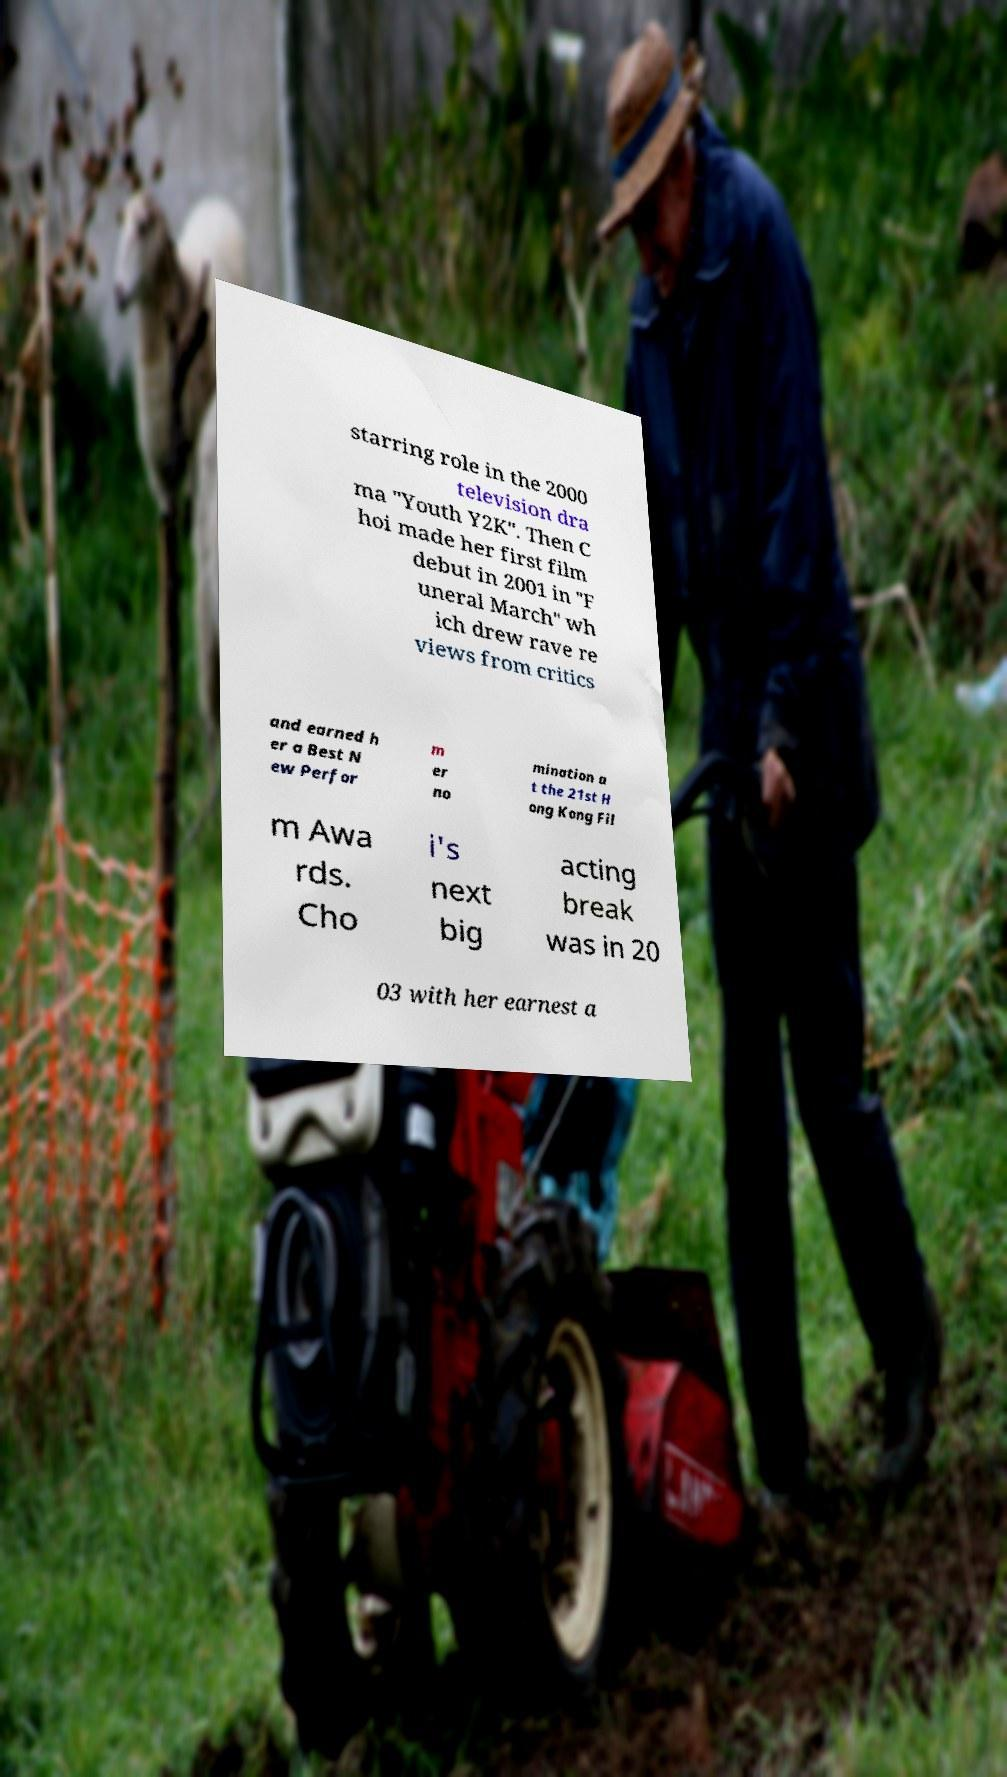Can you read and provide the text displayed in the image?This photo seems to have some interesting text. Can you extract and type it out for me? starring role in the 2000 television dra ma "Youth Y2K". Then C hoi made her first film debut in 2001 in "F uneral March" wh ich drew rave re views from critics and earned h er a Best N ew Perfor m er no mination a t the 21st H ong Kong Fil m Awa rds. Cho i's next big acting break was in 20 03 with her earnest a 